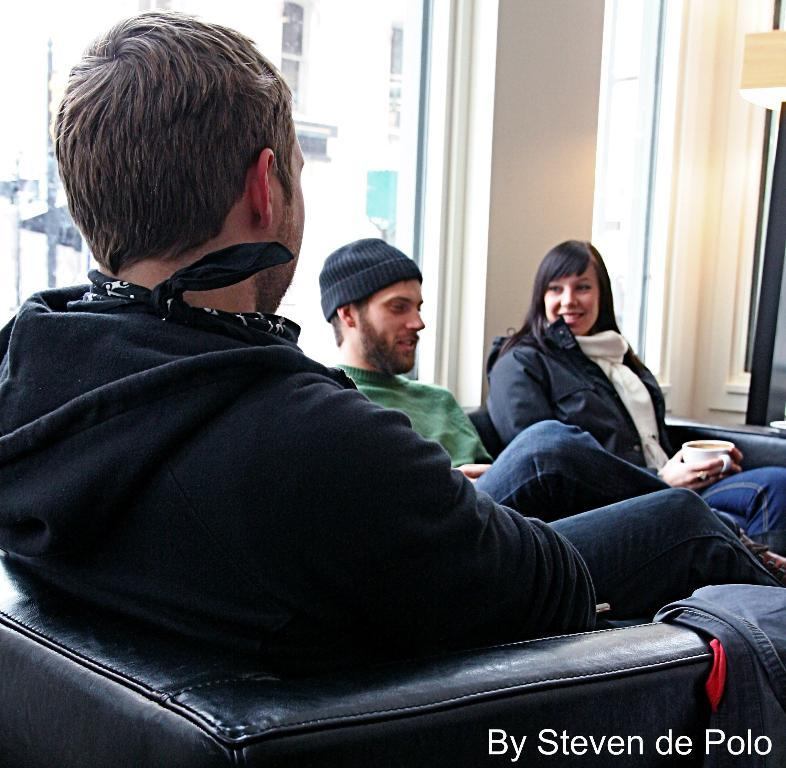What is the main subject in the center of the image? There is a person sitting on a chair in the center of the image. Can you describe the background of the image? In the background, there is another person sitting, a building, a light source, a wall, and a window. How many people are visible in the image? There are two people visible in the image. What type of trucks can be seen in the frame of the image? There are no trucks present in the image. Who is the father of the person sitting on the chair in the image? The provided facts do not mention any information about the person's father, so it cannot be determined from the image. 